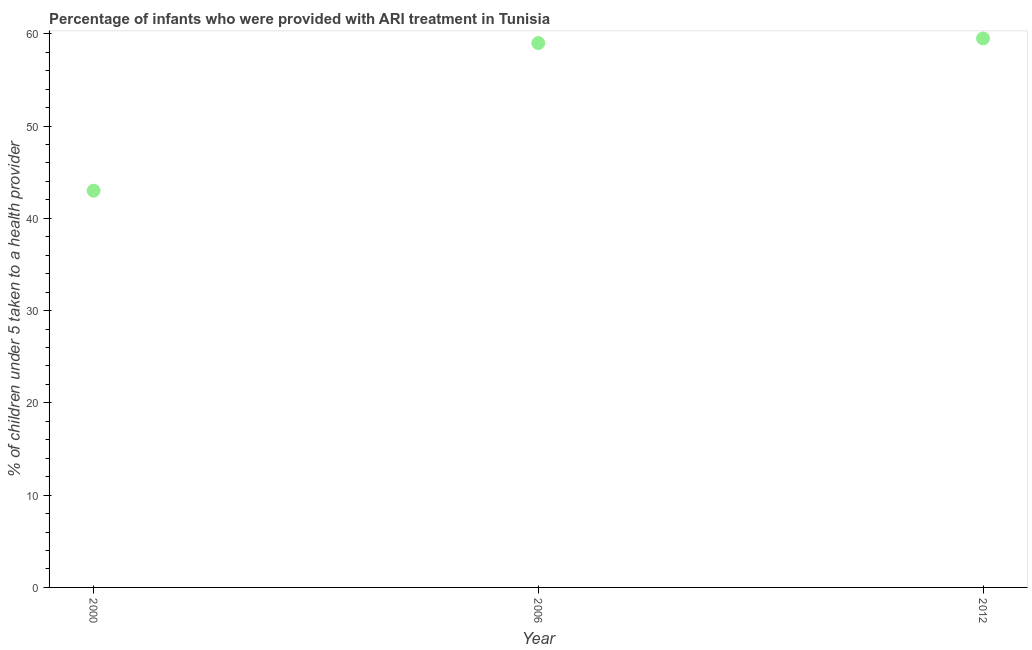Across all years, what is the maximum percentage of children who were provided with ari treatment?
Provide a succinct answer. 59.5. In which year was the percentage of children who were provided with ari treatment minimum?
Your answer should be compact. 2000. What is the sum of the percentage of children who were provided with ari treatment?
Your answer should be compact. 161.5. What is the average percentage of children who were provided with ari treatment per year?
Provide a succinct answer. 53.83. In how many years, is the percentage of children who were provided with ari treatment greater than 14 %?
Make the answer very short. 3. Do a majority of the years between 2012 and 2000 (inclusive) have percentage of children who were provided with ari treatment greater than 44 %?
Your answer should be compact. No. What is the ratio of the percentage of children who were provided with ari treatment in 2000 to that in 2006?
Keep it short and to the point. 0.73. Is the percentage of children who were provided with ari treatment in 2000 less than that in 2006?
Your answer should be compact. Yes. Is the difference between the percentage of children who were provided with ari treatment in 2006 and 2012 greater than the difference between any two years?
Make the answer very short. No. What is the difference between the highest and the second highest percentage of children who were provided with ari treatment?
Your answer should be very brief. 0.5. In how many years, is the percentage of children who were provided with ari treatment greater than the average percentage of children who were provided with ari treatment taken over all years?
Give a very brief answer. 2. Are the values on the major ticks of Y-axis written in scientific E-notation?
Your response must be concise. No. What is the title of the graph?
Offer a terse response. Percentage of infants who were provided with ARI treatment in Tunisia. What is the label or title of the X-axis?
Provide a succinct answer. Year. What is the label or title of the Y-axis?
Keep it short and to the point. % of children under 5 taken to a health provider. What is the % of children under 5 taken to a health provider in 2000?
Your answer should be very brief. 43. What is the % of children under 5 taken to a health provider in 2006?
Your answer should be compact. 59. What is the % of children under 5 taken to a health provider in 2012?
Your answer should be compact. 59.5. What is the difference between the % of children under 5 taken to a health provider in 2000 and 2012?
Keep it short and to the point. -16.5. What is the difference between the % of children under 5 taken to a health provider in 2006 and 2012?
Provide a succinct answer. -0.5. What is the ratio of the % of children under 5 taken to a health provider in 2000 to that in 2006?
Give a very brief answer. 0.73. What is the ratio of the % of children under 5 taken to a health provider in 2000 to that in 2012?
Provide a succinct answer. 0.72. 